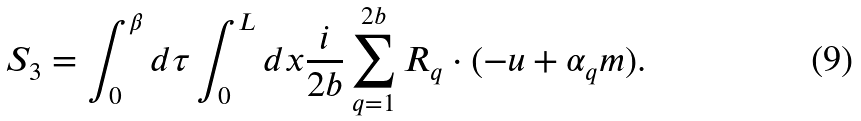<formula> <loc_0><loc_0><loc_500><loc_500>S _ { 3 } = \int ^ { \beta } _ { 0 } d \tau \int ^ { L } _ { 0 } d x \frac { i } { 2 b } \sum _ { q = 1 } ^ { 2 b } { R } _ { q } \cdot ( - { u } + \alpha _ { q } { m } ) .</formula> 